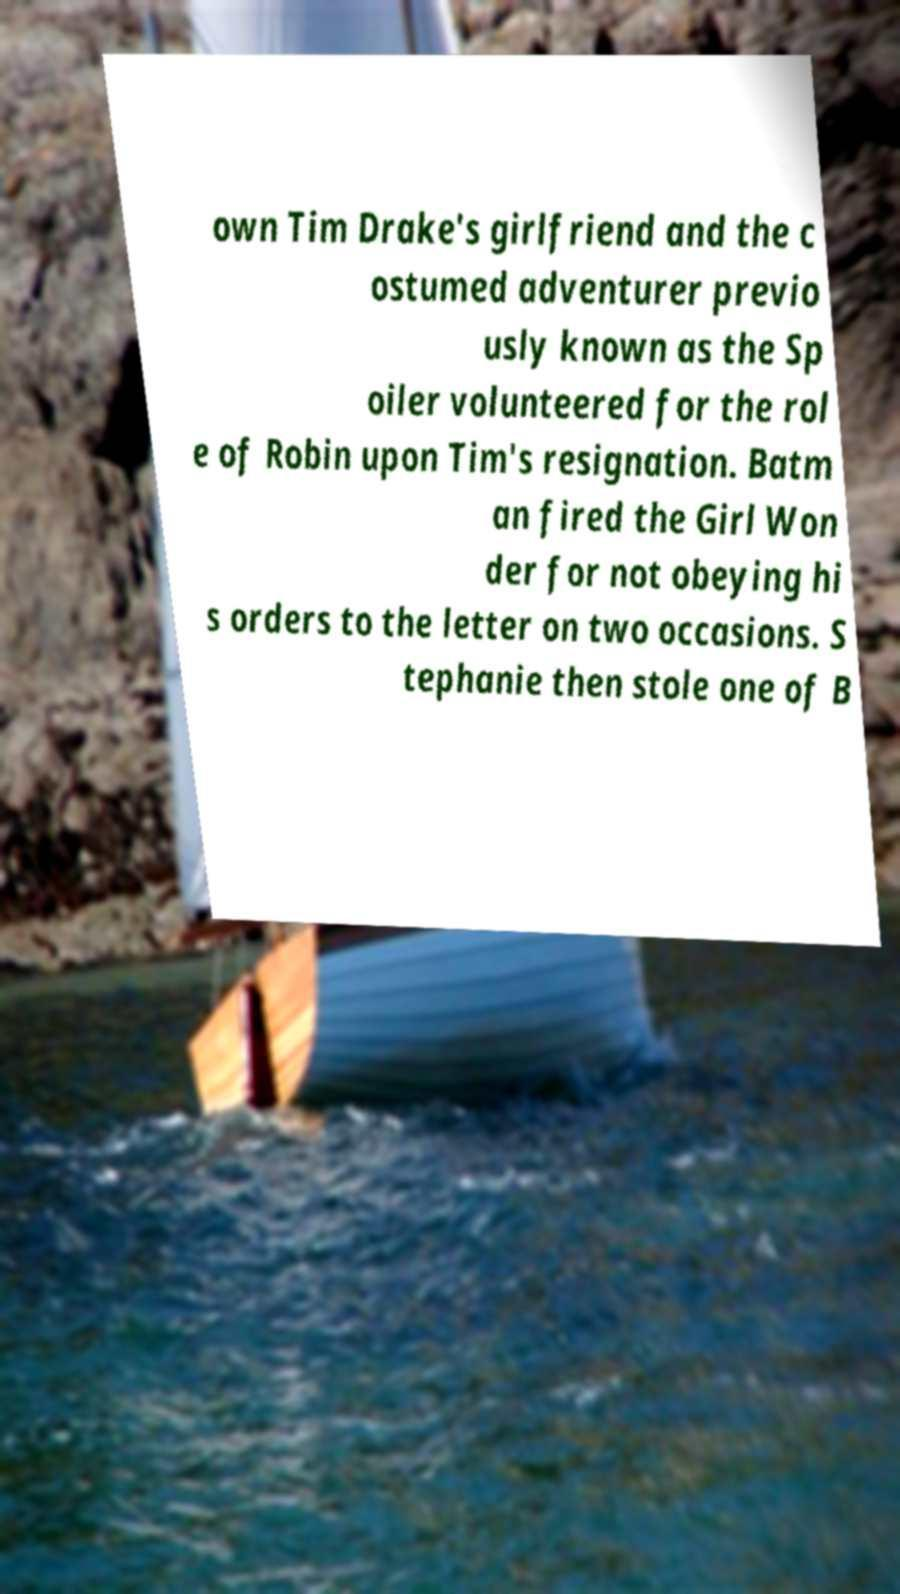Can you accurately transcribe the text from the provided image for me? own Tim Drake's girlfriend and the c ostumed adventurer previo usly known as the Sp oiler volunteered for the rol e of Robin upon Tim's resignation. Batm an fired the Girl Won der for not obeying hi s orders to the letter on two occasions. S tephanie then stole one of B 